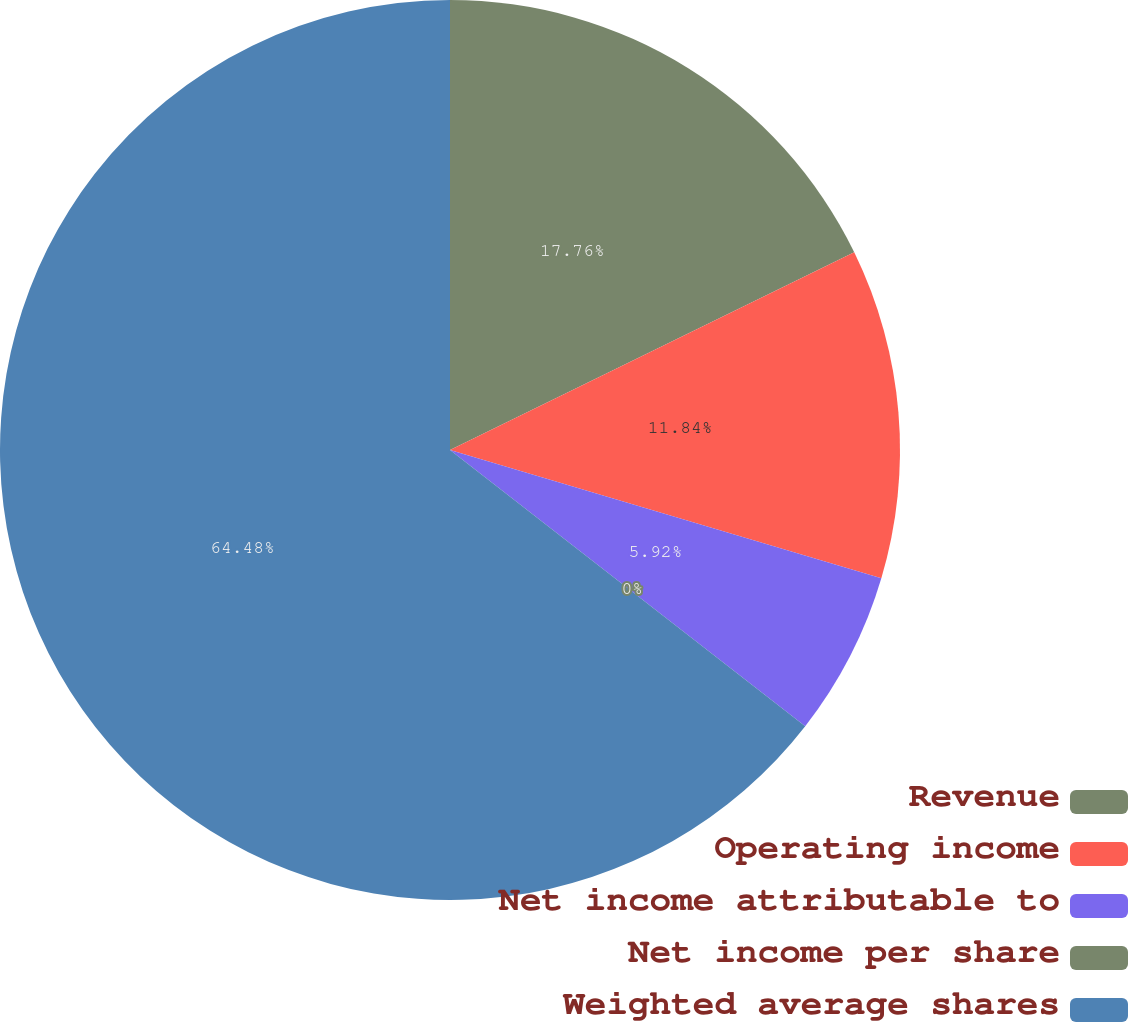<chart> <loc_0><loc_0><loc_500><loc_500><pie_chart><fcel>Revenue<fcel>Operating income<fcel>Net income attributable to<fcel>Net income per share<fcel>Weighted average shares<nl><fcel>17.76%<fcel>11.84%<fcel>5.92%<fcel>0.0%<fcel>64.48%<nl></chart> 